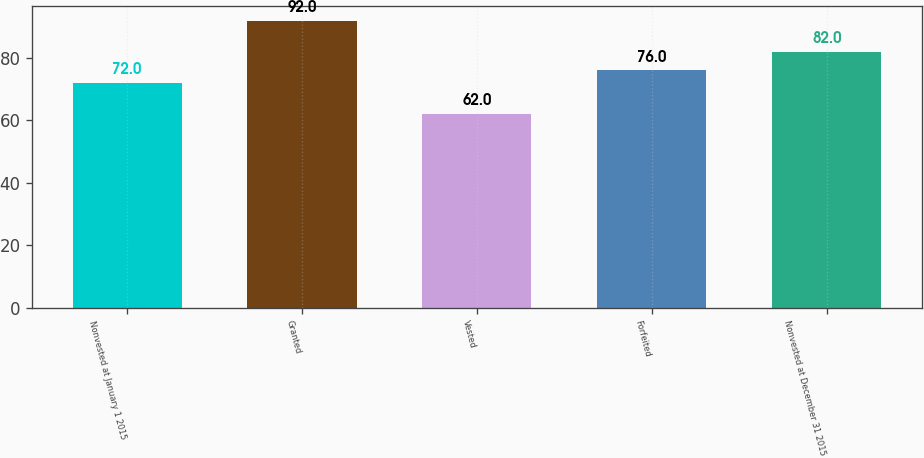<chart> <loc_0><loc_0><loc_500><loc_500><bar_chart><fcel>Nonvested at January 1 2015<fcel>Granted<fcel>Vested<fcel>Forfeited<fcel>Nonvested at December 31 2015<nl><fcel>72<fcel>92<fcel>62<fcel>76<fcel>82<nl></chart> 